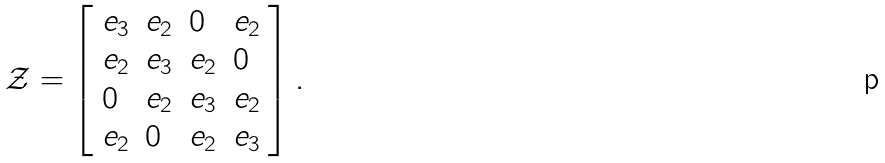Convert formula to latex. <formula><loc_0><loc_0><loc_500><loc_500>\mathcal { Z } = \left [ \begin{array} { l l l l } e _ { 3 } & e _ { 2 } & 0 & e _ { 2 } \\ e _ { 2 } & e _ { 3 } & e _ { 2 } & 0 \\ 0 & e _ { 2 } & e _ { 3 } & e _ { 2 } \\ e _ { 2 } & 0 & e _ { 2 } & e _ { 3 } \end{array} \right ] .</formula> 